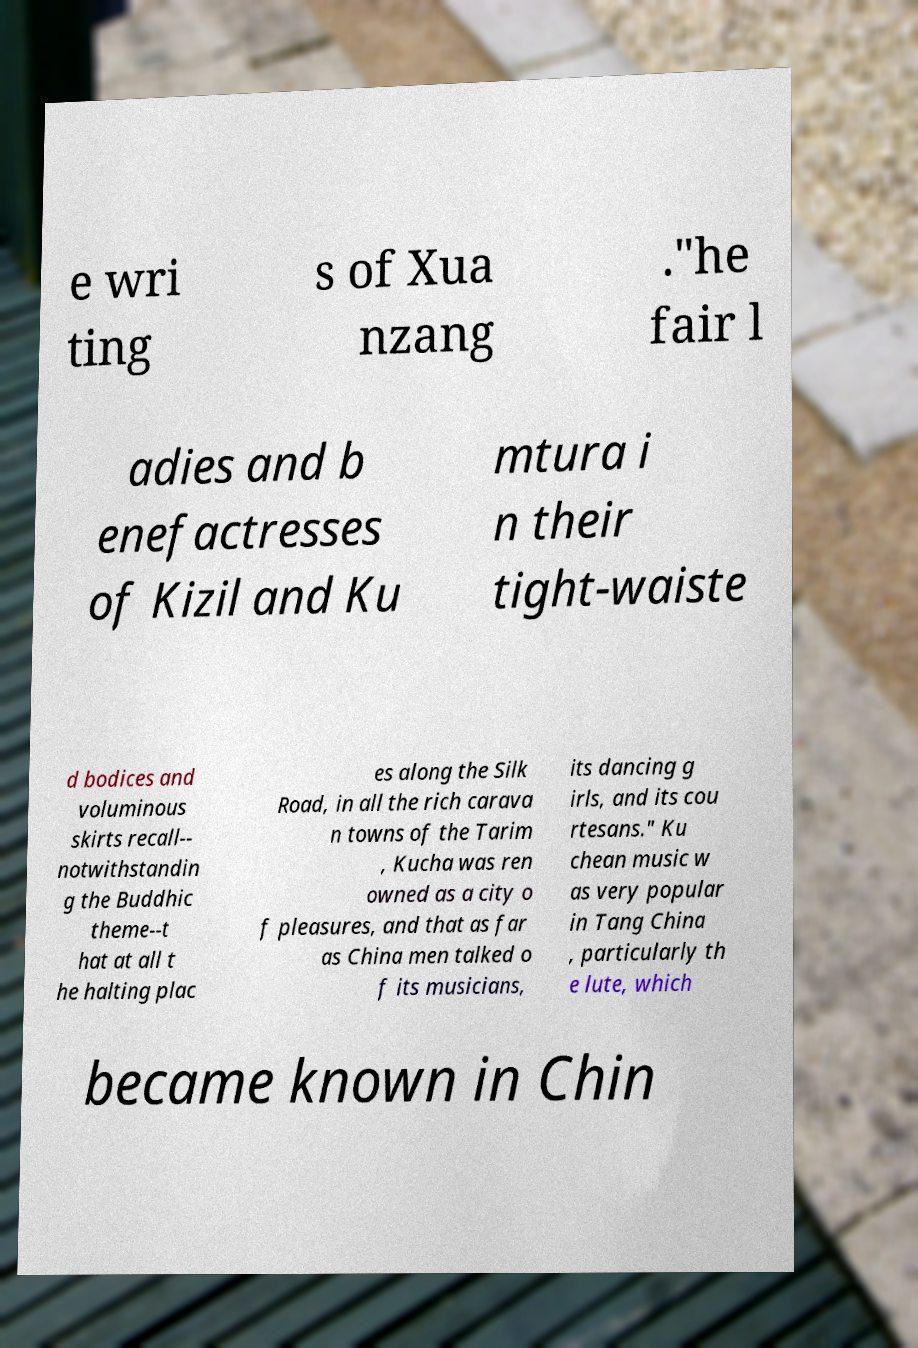Could you extract and type out the text from this image? e wri ting s of Xua nzang ."he fair l adies and b enefactresses of Kizil and Ku mtura i n their tight-waiste d bodices and voluminous skirts recall-- notwithstandin g the Buddhic theme--t hat at all t he halting plac es along the Silk Road, in all the rich carava n towns of the Tarim , Kucha was ren owned as a city o f pleasures, and that as far as China men talked o f its musicians, its dancing g irls, and its cou rtesans." Ku chean music w as very popular in Tang China , particularly th e lute, which became known in Chin 